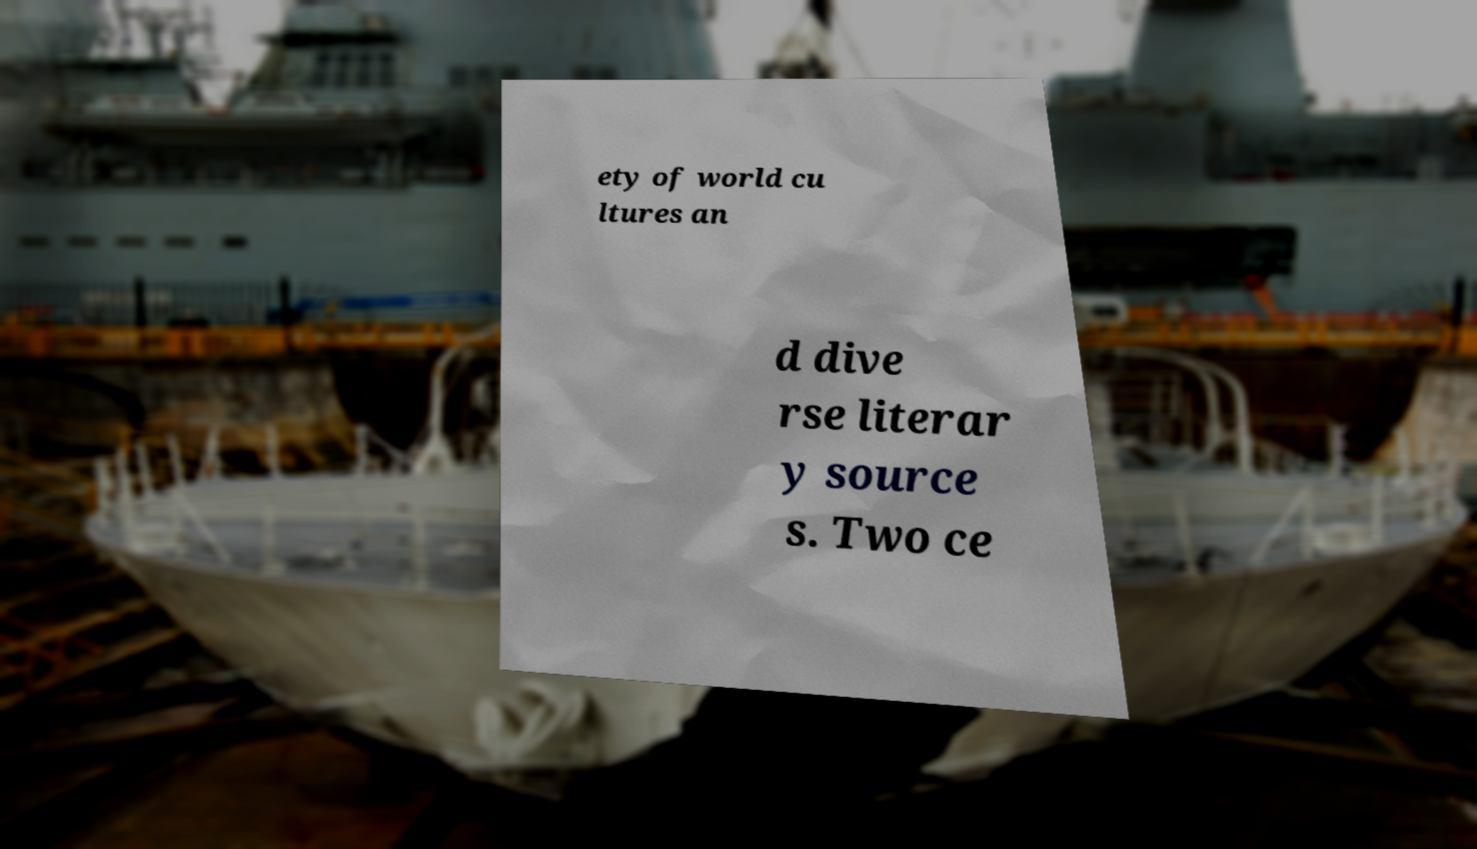I need the written content from this picture converted into text. Can you do that? ety of world cu ltures an d dive rse literar y source s. Two ce 